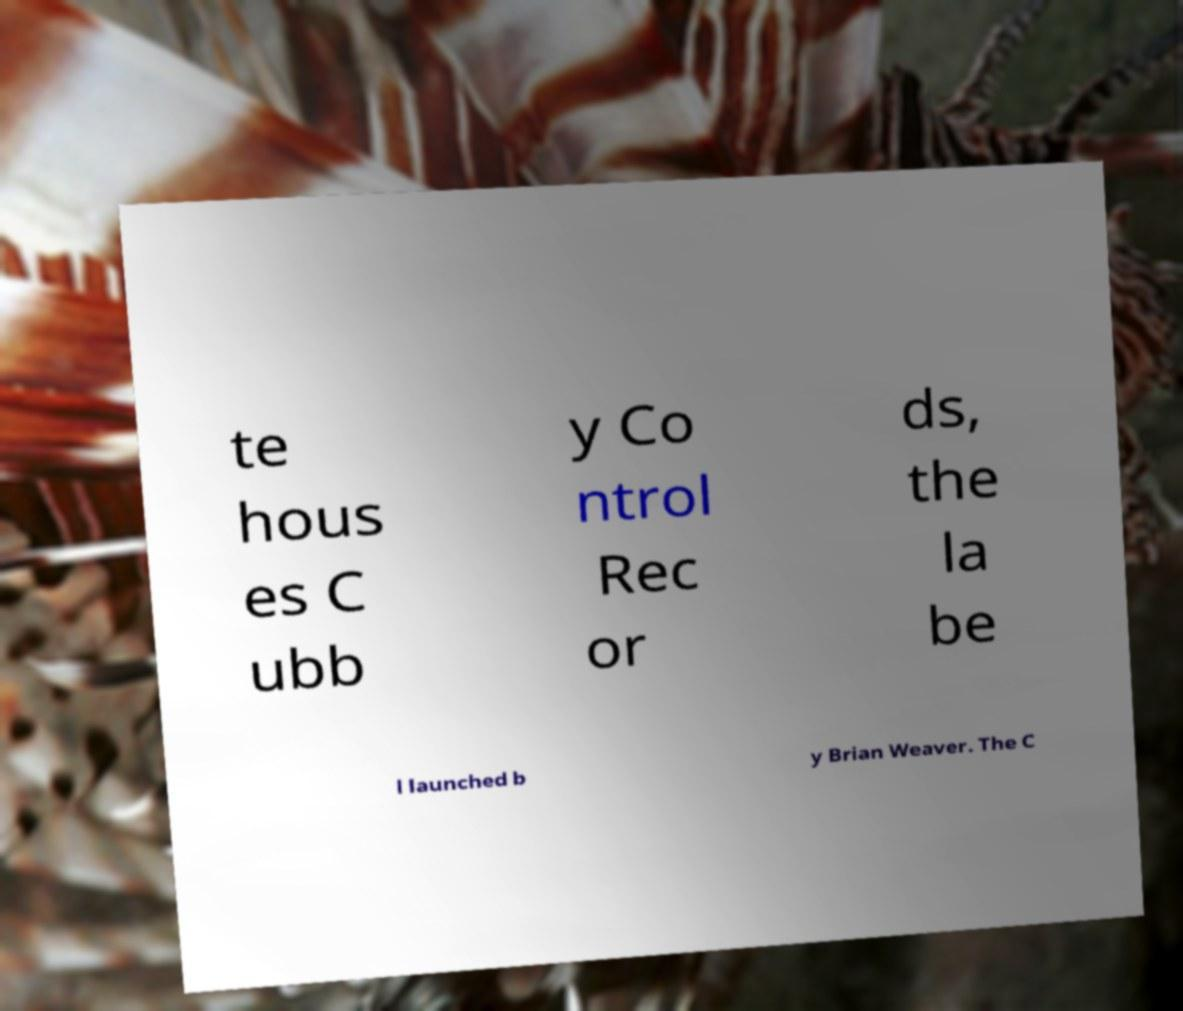Please read and relay the text visible in this image. What does it say? te hous es C ubb y Co ntrol Rec or ds, the la be l launched b y Brian Weaver. The C 